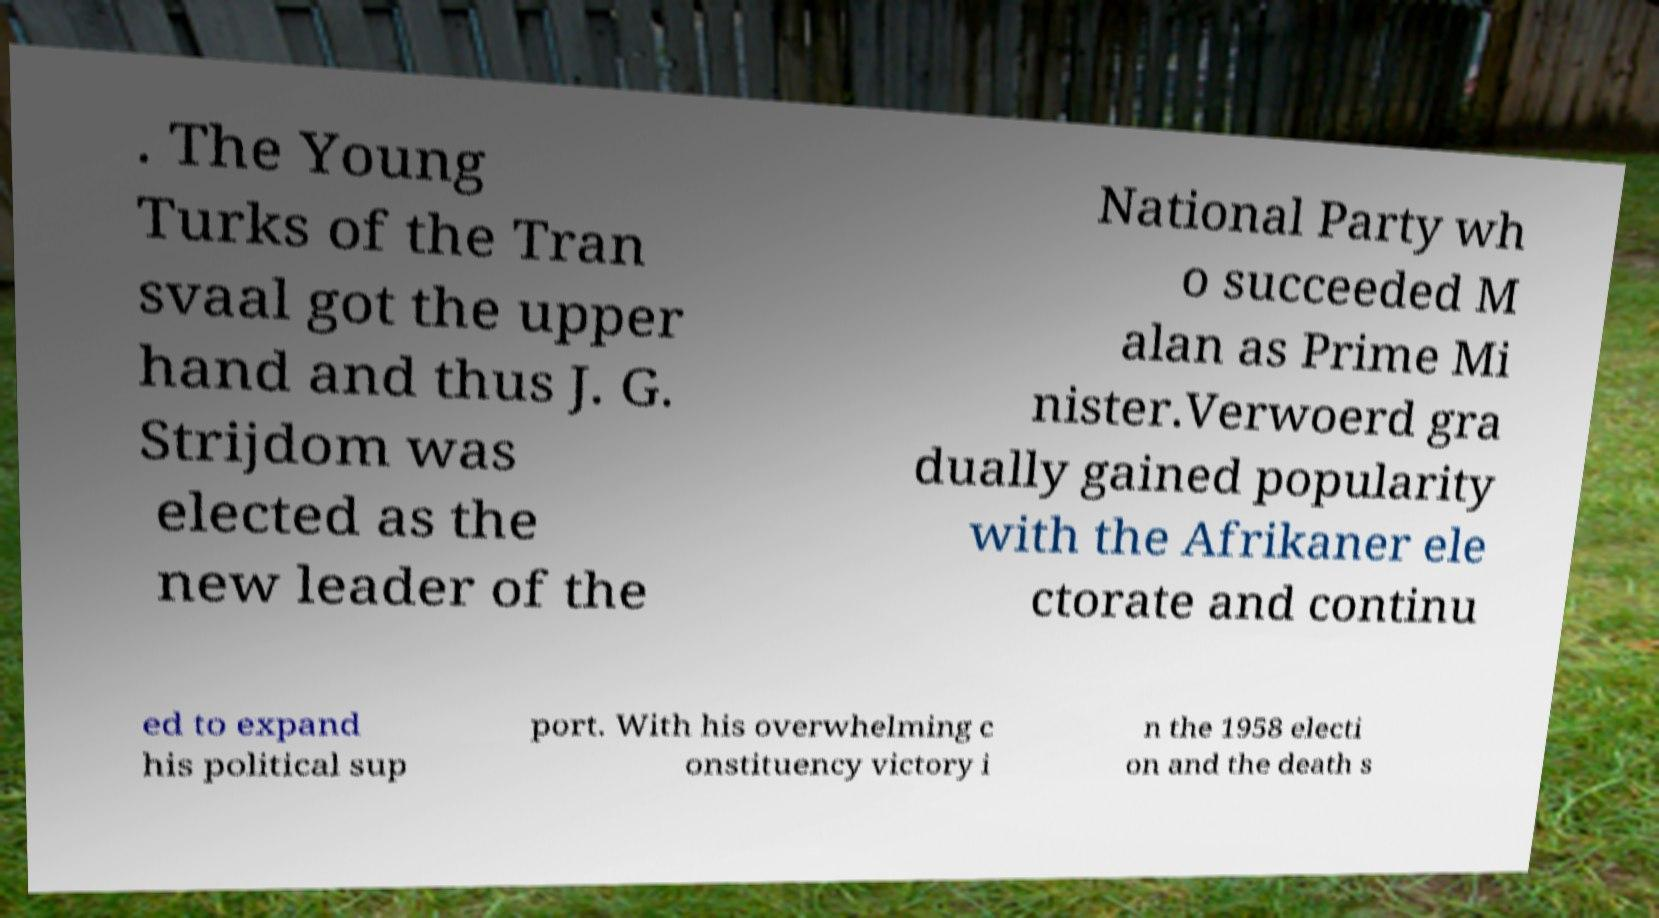Can you read and provide the text displayed in the image?This photo seems to have some interesting text. Can you extract and type it out for me? . The Young Turks of the Tran svaal got the upper hand and thus J. G. Strijdom was elected as the new leader of the National Party wh o succeeded M alan as Prime Mi nister.Verwoerd gra dually gained popularity with the Afrikaner ele ctorate and continu ed to expand his political sup port. With his overwhelming c onstituency victory i n the 1958 electi on and the death s 